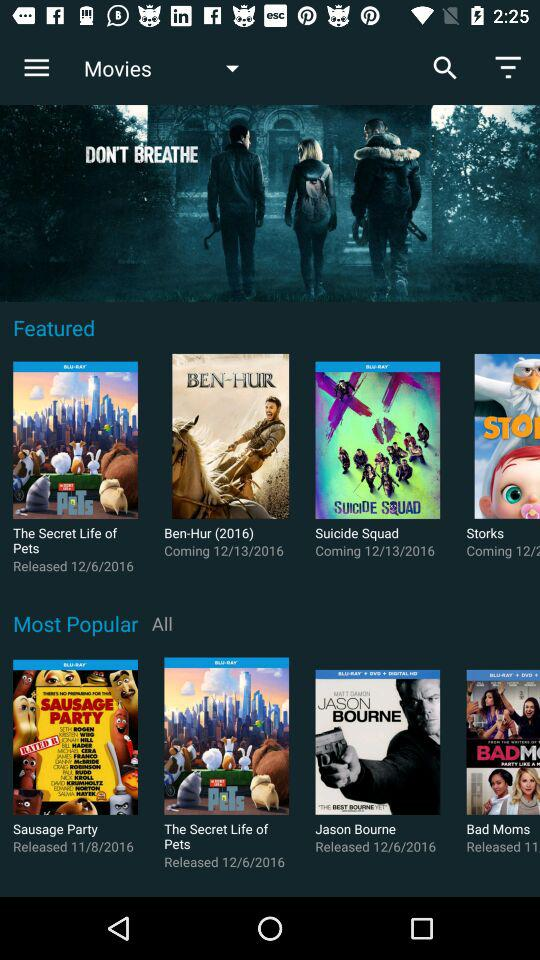What is the release date of the movie "Ben-Hur"? The release date is December 13, 2016. 